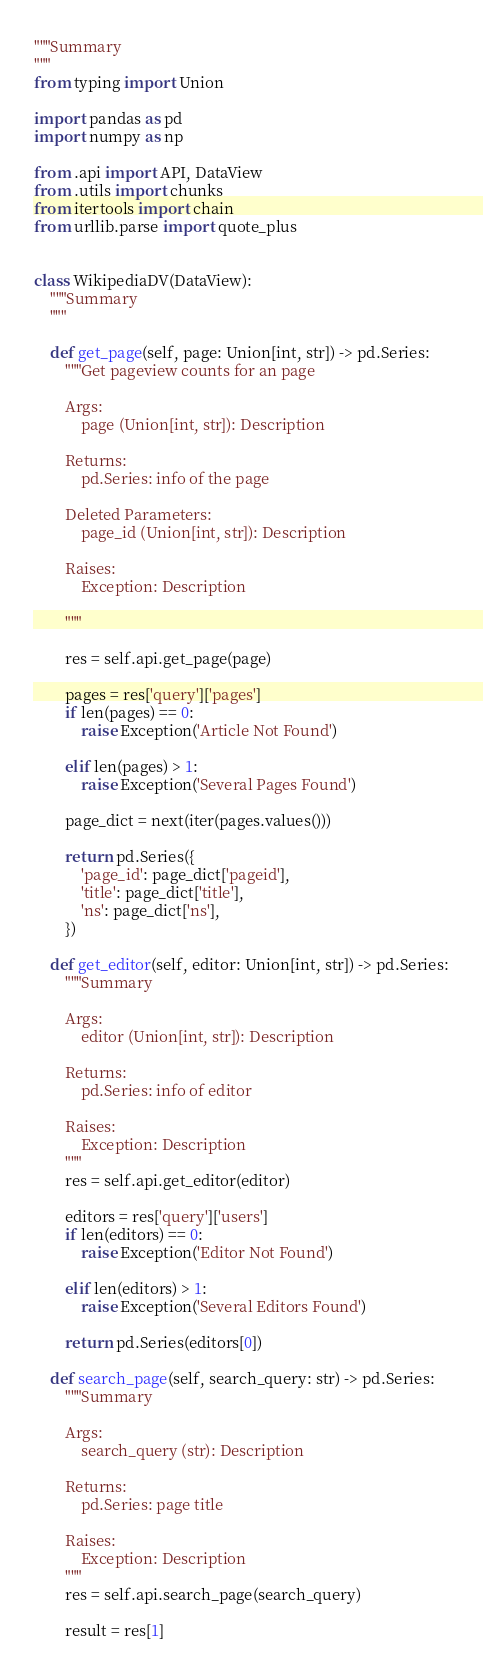Convert code to text. <code><loc_0><loc_0><loc_500><loc_500><_Python_>"""Summary
"""
from typing import Union

import pandas as pd
import numpy as np

from .api import API, DataView
from .utils import chunks
from itertools import chain
from urllib.parse import quote_plus


class WikipediaDV(DataView):
    """Summary
    """

    def get_page(self, page: Union[int, str]) -> pd.Series:
        """Get pageview counts for an page

        Args:
            page (Union[int, str]): Description

        Returns:
            pd.Series: info of the page

        Deleted Parameters:
            page_id (Union[int, str]): Description

        Raises:
            Exception: Description

        """

        res = self.api.get_page(page)

        pages = res['query']['pages']
        if len(pages) == 0:
            raise Exception('Article Not Found')

        elif len(pages) > 1:
            raise Exception('Several Pages Found')

        page_dict = next(iter(pages.values()))

        return pd.Series({
            'page_id': page_dict['pageid'],
            'title': page_dict['title'],
            'ns': page_dict['ns'],
        })

    def get_editor(self, editor: Union[int, str]) -> pd.Series:
        """Summary

        Args:
            editor (Union[int, str]): Description

        Returns:
            pd.Series: info of editor

        Raises:
            Exception: Description
        """
        res = self.api.get_editor(editor)

        editors = res['query']['users']
        if len(editors) == 0:
            raise Exception('Editor Not Found')

        elif len(editors) > 1:
            raise Exception('Several Editors Found')

        return pd.Series(editors[0])

    def search_page(self, search_query: str) -> pd.Series:
        """Summary

        Args:
            search_query (str): Description

        Returns:
            pd.Series: page title

        Raises:
            Exception: Description
        """
        res = self.api.search_page(search_query)

        result = res[1]</code> 